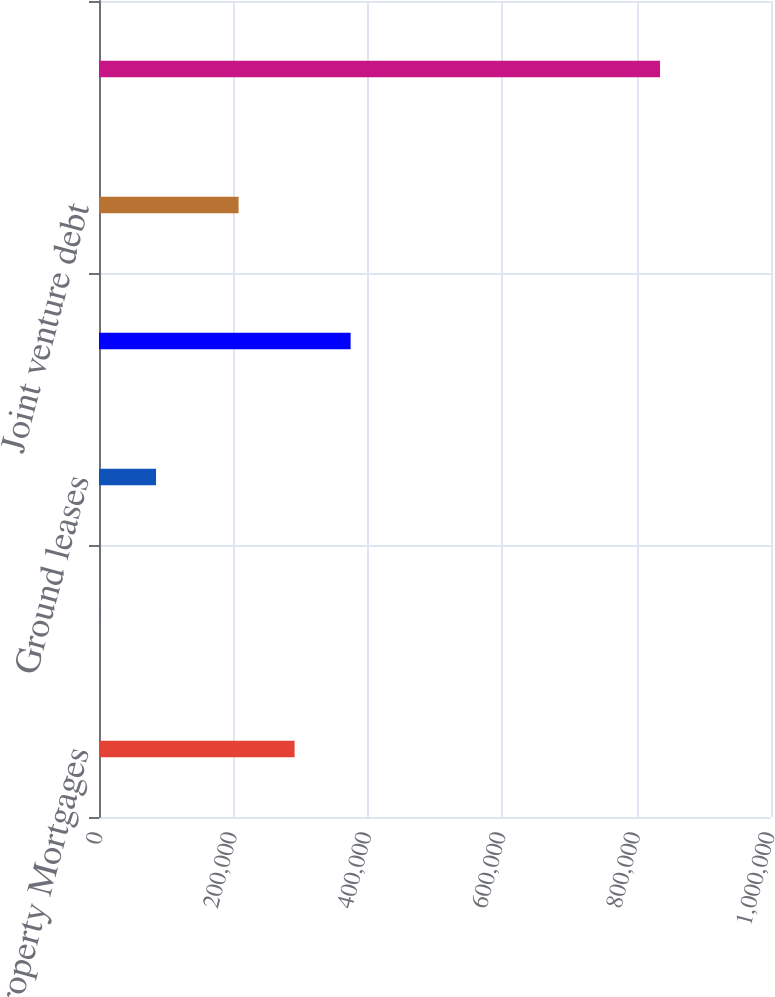Convert chart. <chart><loc_0><loc_0><loc_500><loc_500><bar_chart><fcel>Property Mortgages<fcel>Capital lease<fcel>Ground leases<fcel>Estimated interest expense<fcel>Joint venture debt<fcel>Total<nl><fcel>291073<fcel>1555<fcel>84889.7<fcel>374407<fcel>207738<fcel>834902<nl></chart> 